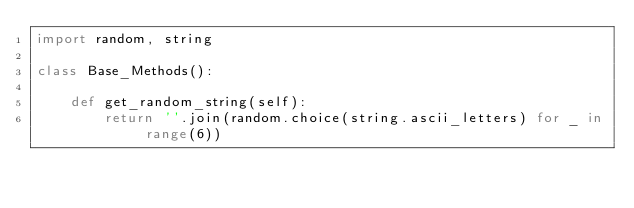<code> <loc_0><loc_0><loc_500><loc_500><_Python_>import random, string

class Base_Methods():
    
    def get_random_string(self):
        return ''.join(random.choice(string.ascii_letters) for _ in range(6))</code> 